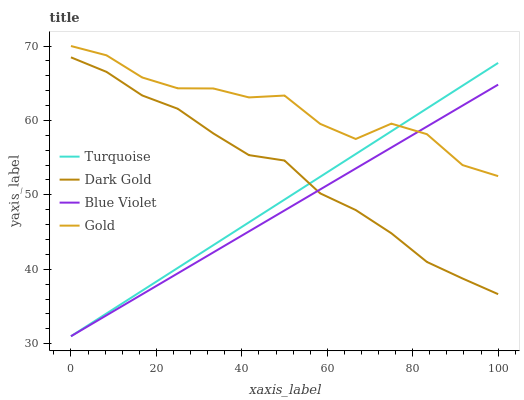Does Blue Violet have the minimum area under the curve?
Answer yes or no. Yes. Does Gold have the maximum area under the curve?
Answer yes or no. Yes. Does Gold have the minimum area under the curve?
Answer yes or no. No. Does Blue Violet have the maximum area under the curve?
Answer yes or no. No. Is Turquoise the smoothest?
Answer yes or no. Yes. Is Gold the roughest?
Answer yes or no. Yes. Is Blue Violet the smoothest?
Answer yes or no. No. Is Blue Violet the roughest?
Answer yes or no. No. Does Gold have the lowest value?
Answer yes or no. No. Does Blue Violet have the highest value?
Answer yes or no. No. Is Dark Gold less than Gold?
Answer yes or no. Yes. Is Gold greater than Dark Gold?
Answer yes or no. Yes. Does Dark Gold intersect Gold?
Answer yes or no. No. 